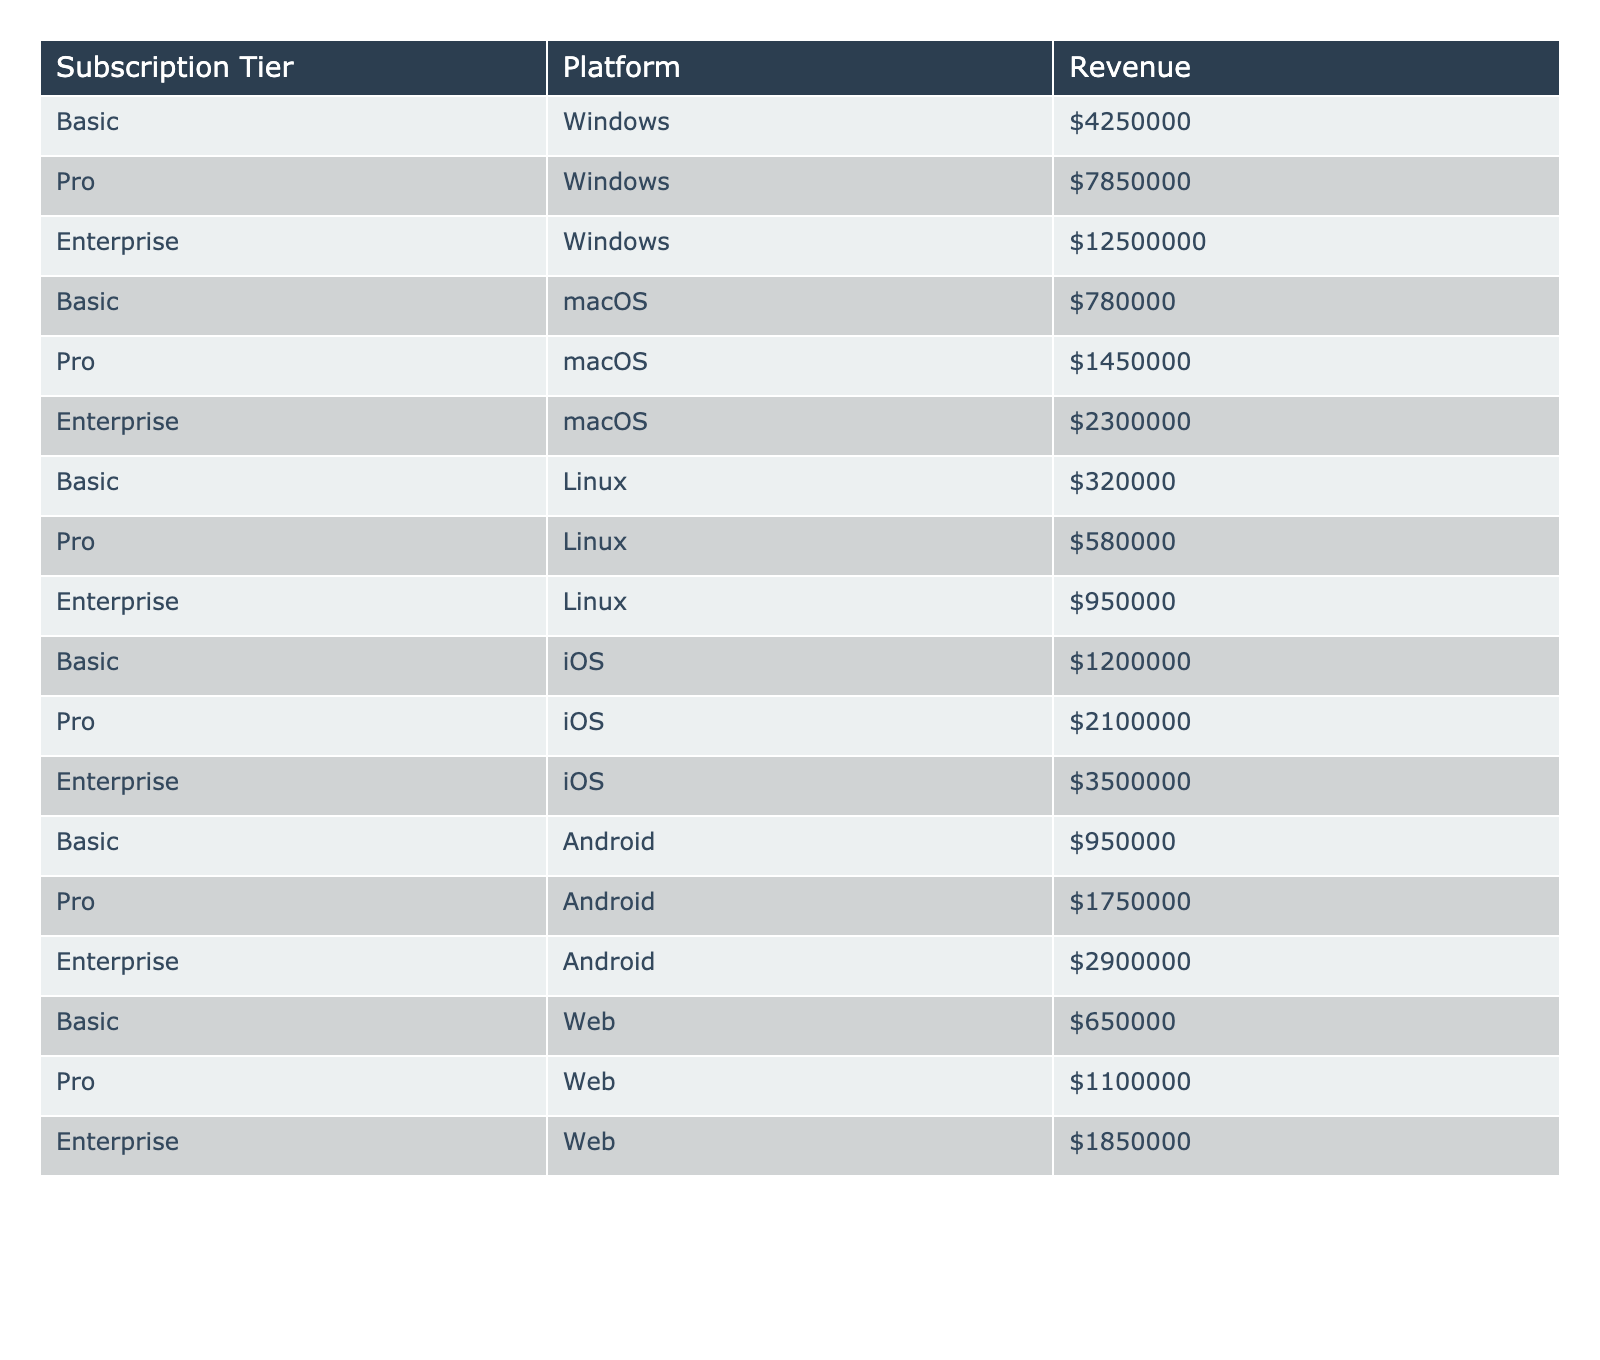What is the total revenue from the Windows platform? The total revenue for the Windows platform includes the revenues from all subscription tiers: Basic ($4,250,000), Pro ($7,850,000), and Enterprise ($12,500,000). Adding these together gives $4,250,000 + $7,850,000 + $12,500,000 = $24,600,000.
Answer: $24,600,000 Which subscription tier generates the highest revenue on the macOS platform? The revenues for the macOS platform across subscription tiers are: Basic ($780,000), Pro ($1,450,000), and Enterprise ($2,300,000). The highest is the Enterprise tier at $2,300,000.
Answer: Enterprise What is the combined revenue of the Basic subscription tier across all platforms? The combined revenue of the Basic tier can be found by summing its revenues across all platforms: Windows ($4,250,000), macOS ($780,000), Linux ($320,000), iOS ($1,200,000), Android ($950,000), and Web ($650,000). The total is $4,250,000 + $780,000 + $320,000 + $1,200,000 + $950,000 + $650,000 = $8,150,000.
Answer: $8,150,000 Is the revenue from the Android platform greater than the revenue from the iOS platform? The Android platform generates $2,900,000 (Enterprise) + $1,750,000 (Pro) + $950,000 (Basic) = $5,600,000, while the iOS platform generates $3,500,000 (Enterprise) + $2,100,000 (Pro) + $1,200,000 (Basic) = $6,800,000. Since $5,600,000 is less than $6,800,000, the statement is false.
Answer: No Which platform contributes the lowest revenue for the Enterprise subscription tier? The Enterprise revenues across platforms are: Windows ($12,500,000), macOS ($2,300,000), Linux ($950,000), iOS ($3,500,000), Android ($2,900,000), and Web ($1,850,000). The lowest is the Linux platform with $950,000.
Answer: Linux What is the average revenue of the Pro subscription tier? For the Pro tier, the revenues are: Windows ($7,850,000), macOS ($1,450,000), Linux ($580,000), iOS ($2,100,000), Android ($1,750,000), and Web ($1,100,000). Summing these gives $7,850,000 + $1,450,000 + $580,000 + $2,100,000 + $1,750,000 + $1,100,000 = $14,830,000. There are 6 platforms, so the average is $14,830,000 / 6 = $2,471,666.67.
Answer: $2,471,667 What is the total revenue for the Basic tier compared to the total revenue for the Pro tier? The total revenue for the Basic tier is $8,150,000 (previously calculated). The total for the Pro tier is $14,830,000 (previously calculated). The Basic tier is less than the Pro tier since $8,150,000 is less than $14,830,000.
Answer: Basic is less If we were to remove the Linux platform from the data, what would be the new total revenue across all platforms for the Enterprise tier? The total revenue for the Enterprise tier would be recalculated without Linux. The remaining platforms are: Windows ($12,500,000), macOS ($2,300,000), iOS ($3,500,000), Android ($2,900,000), and Web ($1,850,000). Summing these gives: $12,500,000 + $2,300,000 + $3,500,000 + $2,900,000 + $1,850,000 = $23,050,000.
Answer: $23,050,000 